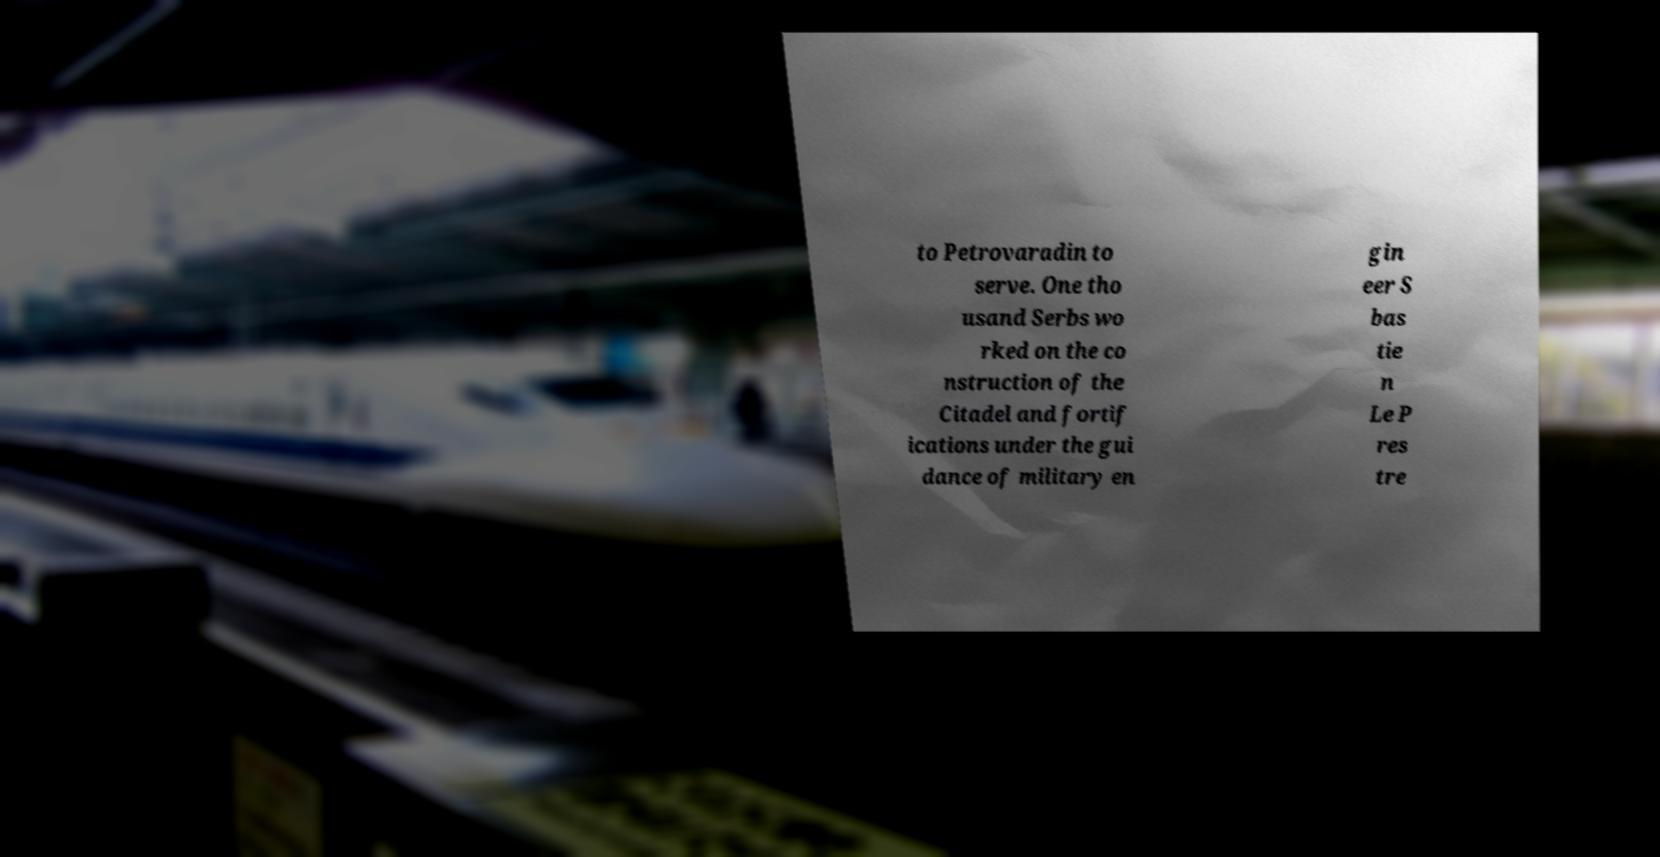There's text embedded in this image that I need extracted. Can you transcribe it verbatim? to Petrovaradin to serve. One tho usand Serbs wo rked on the co nstruction of the Citadel and fortif ications under the gui dance of military en gin eer S bas tie n Le P res tre 